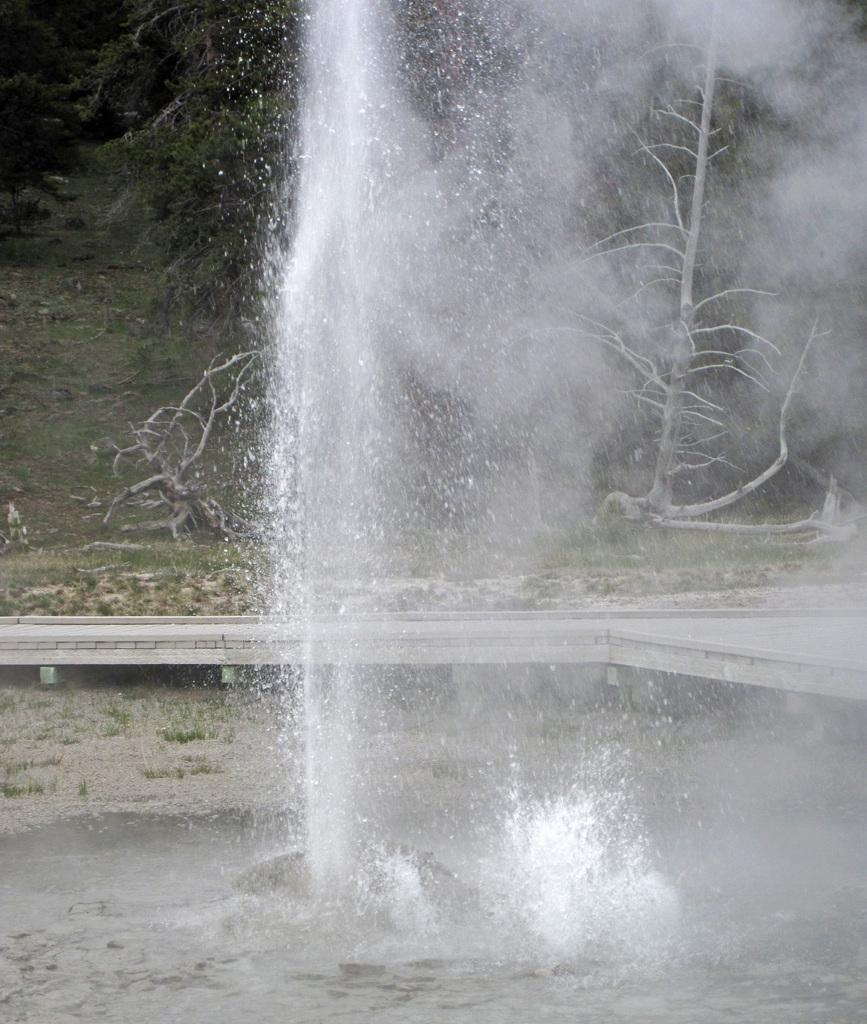What is the main subject in the foreground of the image? There is a water fountain in the foreground of the image. What can be seen in the background of the image? There are trees and the ground visible in the background of the image. What type of plantation is visible in the image? There is no plantation present in the image. 